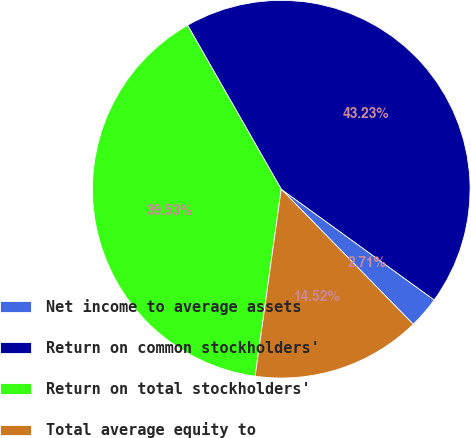<chart> <loc_0><loc_0><loc_500><loc_500><pie_chart><fcel>Net income to average assets<fcel>Return on common stockholders'<fcel>Return on total stockholders'<fcel>Total average equity to<nl><fcel>2.71%<fcel>43.23%<fcel>39.53%<fcel>14.52%<nl></chart> 